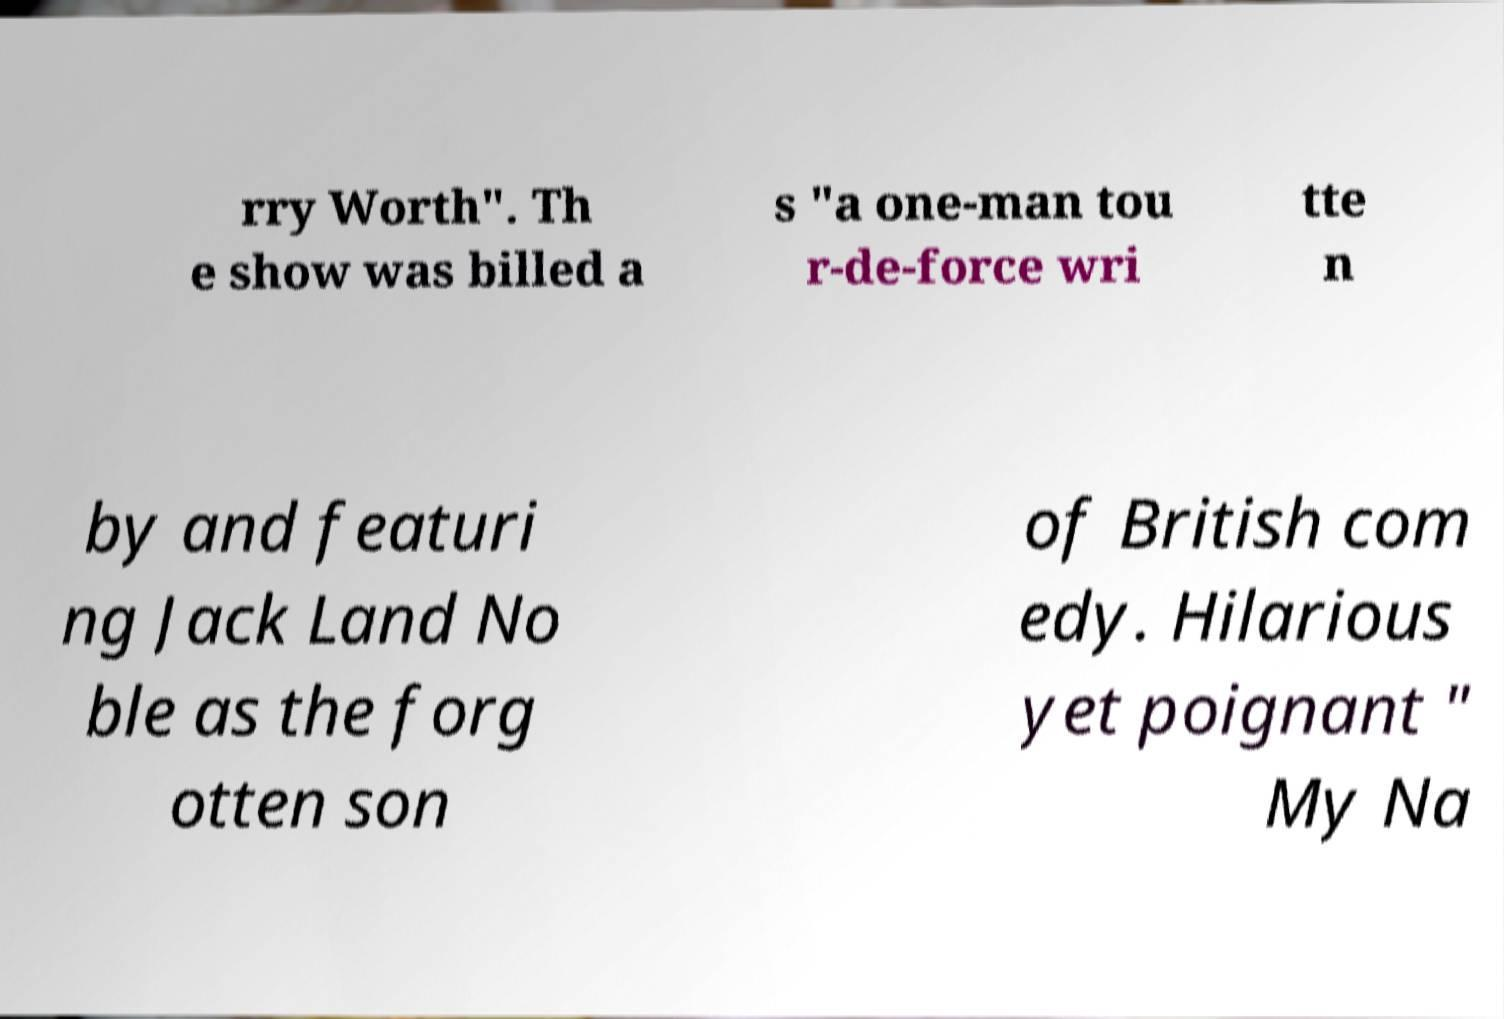I need the written content from this picture converted into text. Can you do that? rry Worth". Th e show was billed a s "a one-man tou r-de-force wri tte n by and featuri ng Jack Land No ble as the forg otten son of British com edy. Hilarious yet poignant " My Na 